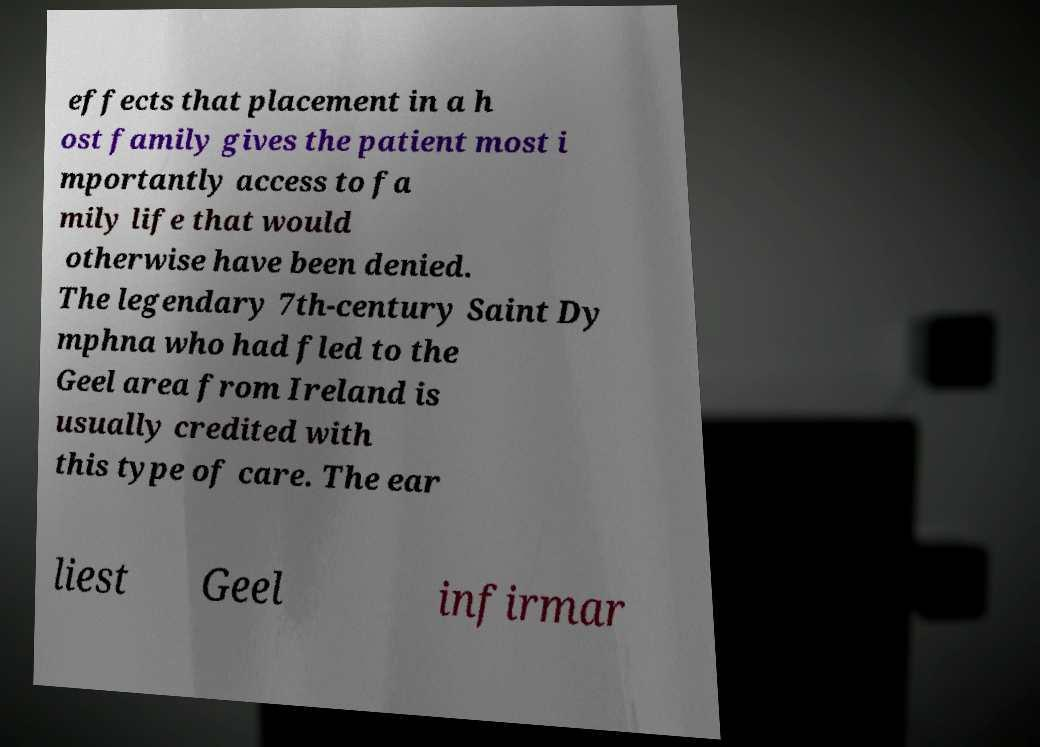I need the written content from this picture converted into text. Can you do that? effects that placement in a h ost family gives the patient most i mportantly access to fa mily life that would otherwise have been denied. The legendary 7th-century Saint Dy mphna who had fled to the Geel area from Ireland is usually credited with this type of care. The ear liest Geel infirmar 